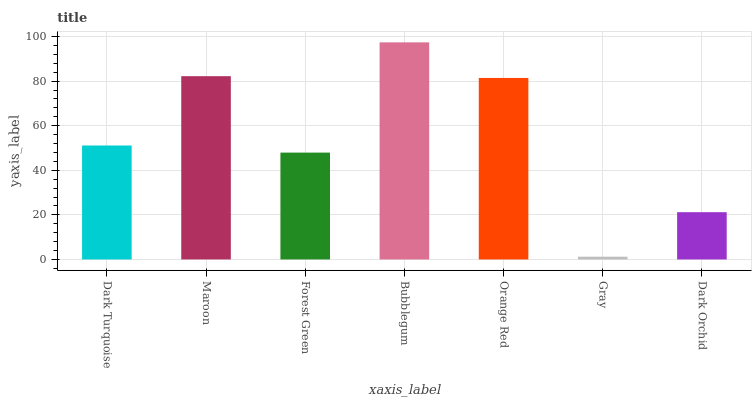Is Gray the minimum?
Answer yes or no. Yes. Is Bubblegum the maximum?
Answer yes or no. Yes. Is Maroon the minimum?
Answer yes or no. No. Is Maroon the maximum?
Answer yes or no. No. Is Maroon greater than Dark Turquoise?
Answer yes or no. Yes. Is Dark Turquoise less than Maroon?
Answer yes or no. Yes. Is Dark Turquoise greater than Maroon?
Answer yes or no. No. Is Maroon less than Dark Turquoise?
Answer yes or no. No. Is Dark Turquoise the high median?
Answer yes or no. Yes. Is Dark Turquoise the low median?
Answer yes or no. Yes. Is Forest Green the high median?
Answer yes or no. No. Is Bubblegum the low median?
Answer yes or no. No. 